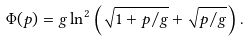Convert formula to latex. <formula><loc_0><loc_0><loc_500><loc_500>\Phi ( p ) = g \ln ^ { 2 } \left ( \sqrt { 1 + p / g } + \sqrt { p / g } \right ) .</formula> 